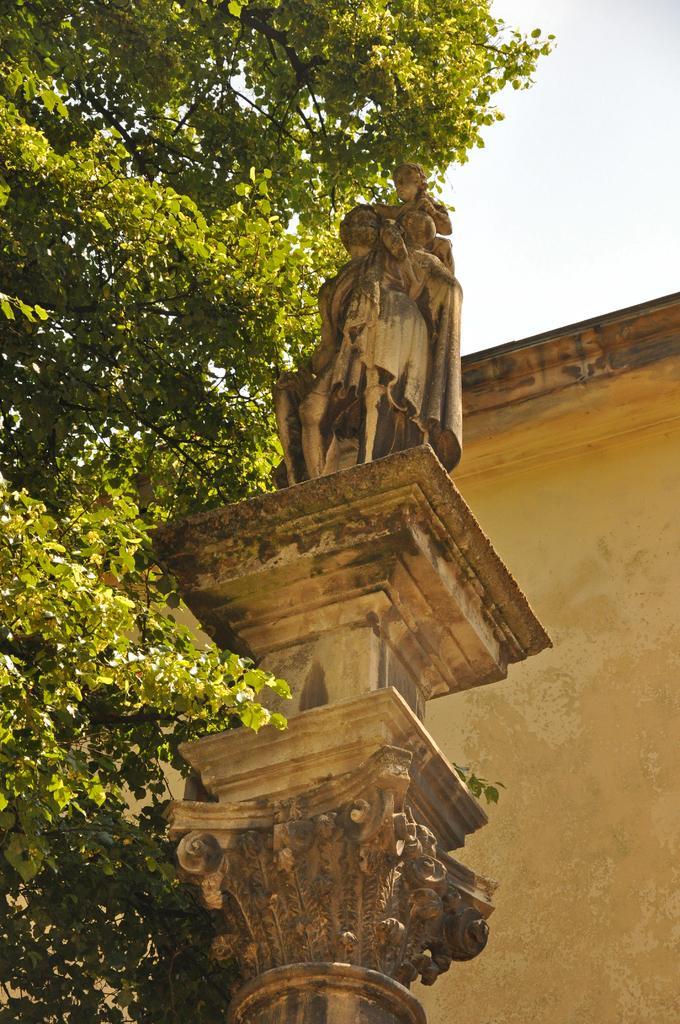Can you describe this image briefly? There is a sculpture, building and a tree. 